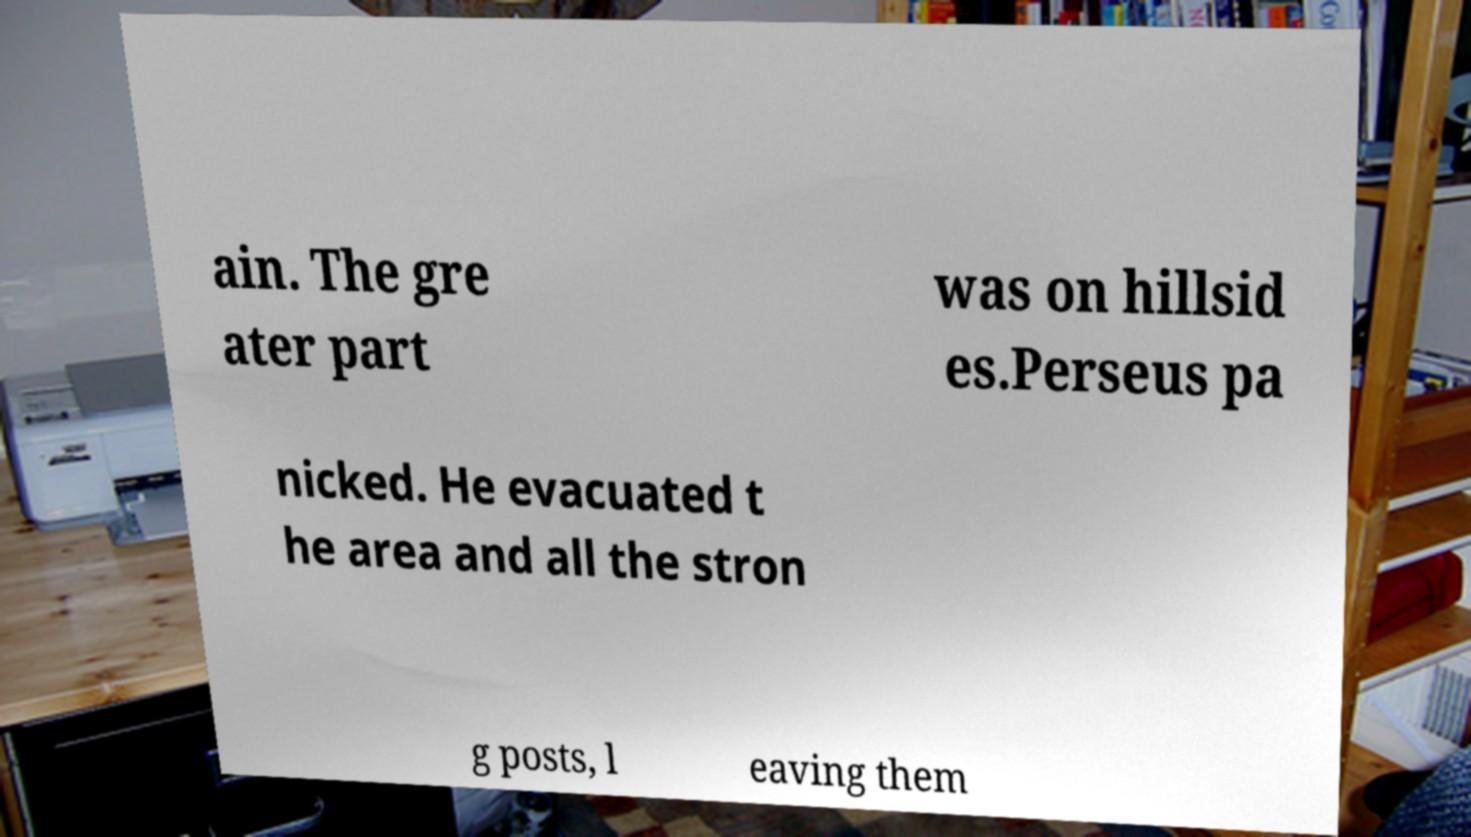There's text embedded in this image that I need extracted. Can you transcribe it verbatim? ain. The gre ater part was on hillsid es.Perseus pa nicked. He evacuated t he area and all the stron g posts, l eaving them 